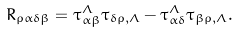Convert formula to latex. <formula><loc_0><loc_0><loc_500><loc_500>R _ { \rho \alpha \delta \beta } = \tau _ { \alpha \beta } ^ { \Lambda } \tau _ { \delta \rho , \Lambda } - \tau _ { \alpha \delta } ^ { \Lambda } \tau _ { \beta \rho , \Lambda } .</formula> 